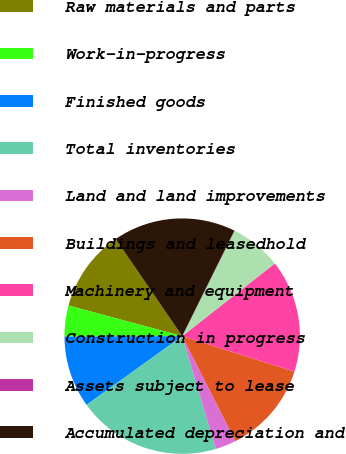<chart> <loc_0><loc_0><loc_500><loc_500><pie_chart><fcel>Raw materials and parts<fcel>Work-in-progress<fcel>Finished goods<fcel>Total inventories<fcel>Land and land improvements<fcel>Buildings and leasedhold<fcel>Machinery and equipment<fcel>Construction in progress<fcel>Assets subject to lease<fcel>Accumulated depreciation and<nl><fcel>11.26%<fcel>4.25%<fcel>9.86%<fcel>19.68%<fcel>2.85%<fcel>12.67%<fcel>15.47%<fcel>7.05%<fcel>0.04%<fcel>16.87%<nl></chart> 